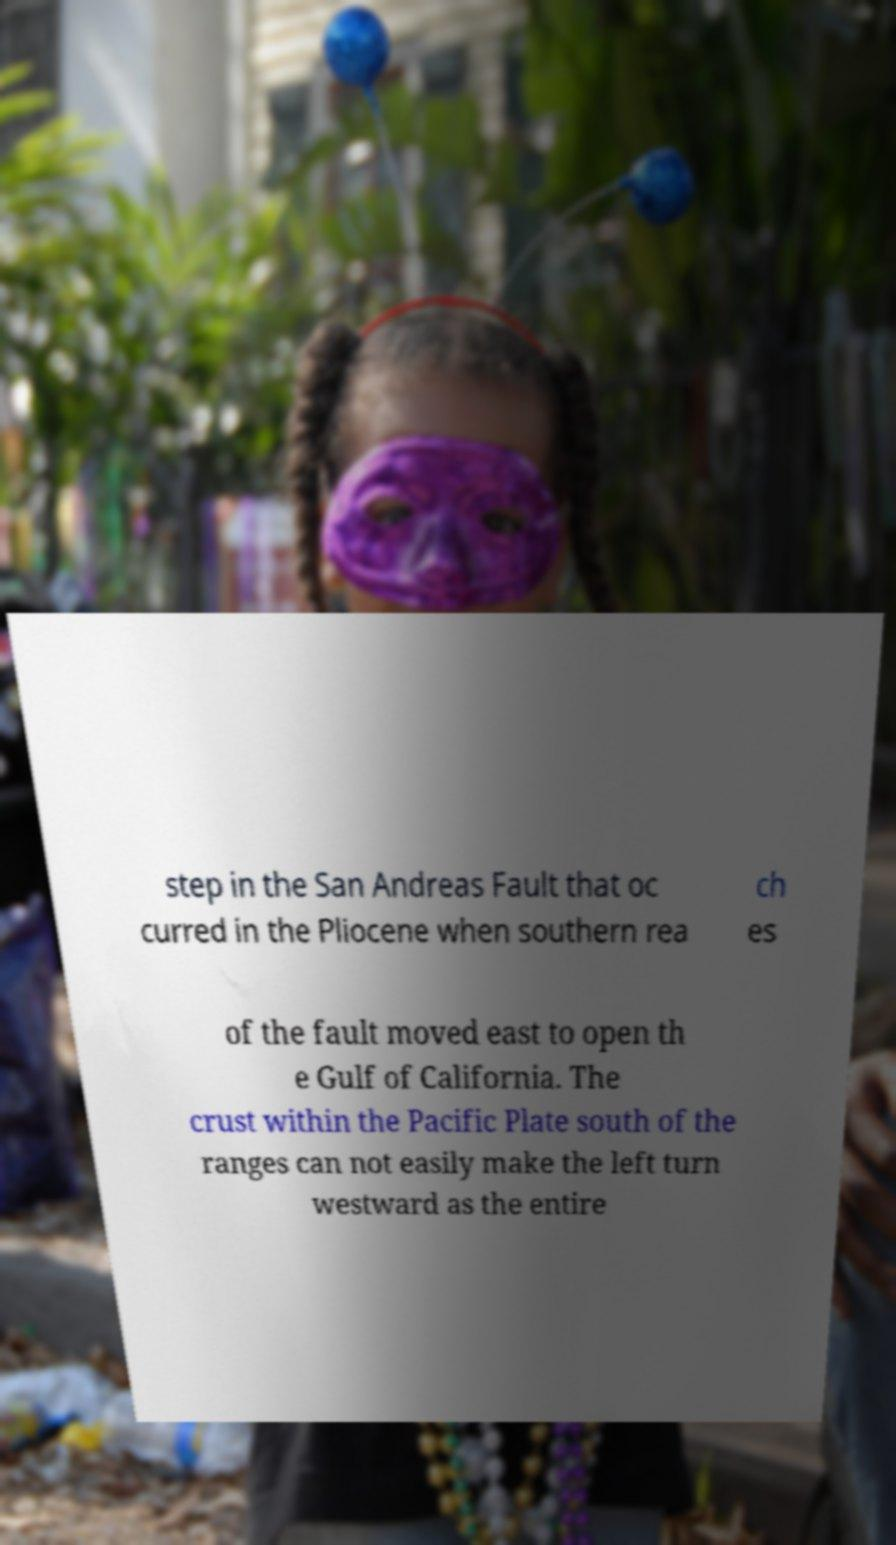I need the written content from this picture converted into text. Can you do that? step in the San Andreas Fault that oc curred in the Pliocene when southern rea ch es of the fault moved east to open th e Gulf of California. The crust within the Pacific Plate south of the ranges can not easily make the left turn westward as the entire 